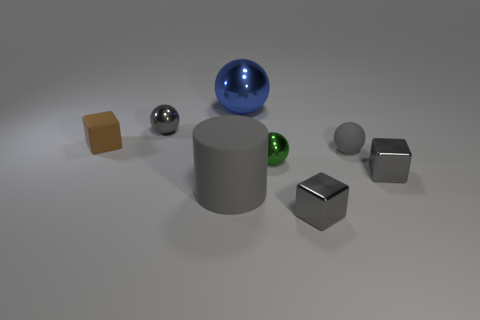What color is the rubber ball to the right of the block left of the green metal sphere?
Offer a terse response. Gray. There is another tiny rubber thing that is the same shape as the blue object; what is its color?
Give a very brief answer. Gray. What number of large matte cylinders have the same color as the large ball?
Keep it short and to the point. 0. There is a rubber cube; does it have the same color as the thing that is in front of the big gray cylinder?
Your answer should be compact. No. There is a tiny gray shiny object that is behind the cylinder and to the right of the small green sphere; what is its shape?
Provide a short and direct response. Cube. There is a cube right of the gray ball that is in front of the small metallic sphere behind the brown block; what is it made of?
Provide a short and direct response. Metal. Are there more green balls that are to the left of the large blue metallic object than small gray metallic things that are right of the big matte object?
Give a very brief answer. No. How many large blue things are the same material as the gray cylinder?
Your answer should be compact. 0. Does the gray metallic object that is to the left of the green thing have the same shape as the small object in front of the big rubber thing?
Give a very brief answer. No. What is the color of the matte thing that is to the right of the big sphere?
Offer a terse response. Gray. 